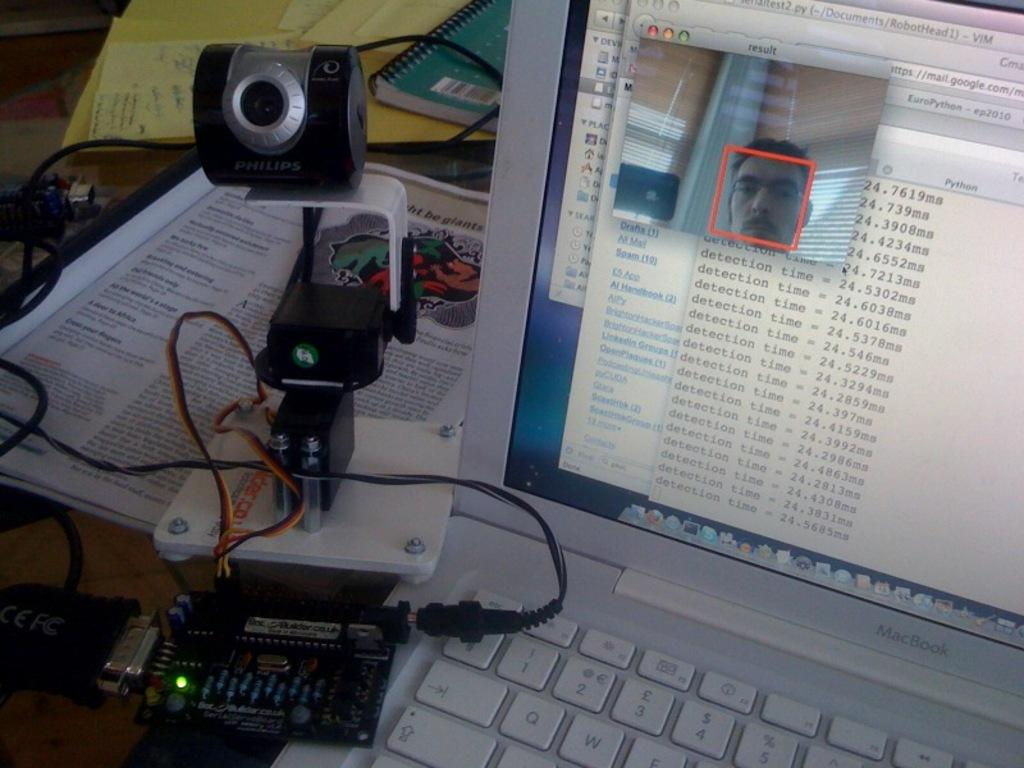What type of laptop is visible in the image? There is a MacBook in the image. What other electronic device can be seen in the image? There is a camera in the image. What type of reading material is present in the image? There are books in the image. Can you describe any other objects in the image? There are other objects in the image, but their specific details are not mentioned in the provided facts. Can you tell me how many worms are crawling on the MacBook in the image? There are no worms present in the image, and therefore no such activity can be observed. What type of ball is visible in the image? There is no ball present in the image. 